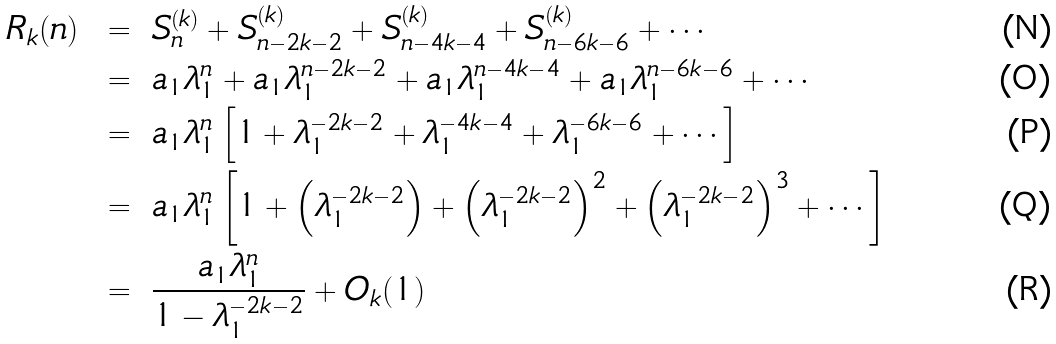<formula> <loc_0><loc_0><loc_500><loc_500>R _ { k } ( n ) \, \ = \ & \, S ^ { ( k ) } _ { n } + S ^ { ( k ) } _ { n - 2 k - 2 } + S ^ { ( k ) } _ { n - 4 k - 4 } + S ^ { ( k ) } _ { n - 6 k - 6 } + \cdots \\ \, \ = \ & \, a _ { 1 } \lambda _ { 1 } ^ { n } + a _ { 1 } \lambda _ { 1 } ^ { n - 2 k - 2 } + a _ { 1 } \lambda _ { 1 } ^ { n - 4 k - 4 } + a _ { 1 } \lambda _ { 1 } ^ { n - 6 k - 6 } + \cdots \\ \, \ = \ & \, a _ { 1 } \lambda _ { 1 } ^ { n } \left [ 1 + \lambda _ { 1 } ^ { - 2 k - 2 } + \lambda _ { 1 } ^ { - 4 k - 4 } + \lambda _ { 1 } ^ { - 6 k - 6 } + \cdots \right ] \\ \, \ = \ & \, a _ { 1 } \lambda _ { 1 } ^ { n } \left [ 1 + \left ( \lambda _ { 1 } ^ { - 2 k - 2 } \right ) + \left ( \lambda _ { 1 } ^ { - 2 k - 2 } \right ) ^ { 2 } + \left ( \lambda _ { 1 } ^ { - 2 k - 2 } \right ) ^ { 3 } + \cdots \right ] \\ \, \ = \ & \, \frac { a _ { 1 } \lambda _ { 1 } ^ { n } } { 1 - \lambda _ { 1 } ^ { - 2 k - 2 } } + O _ { k } ( 1 )</formula> 